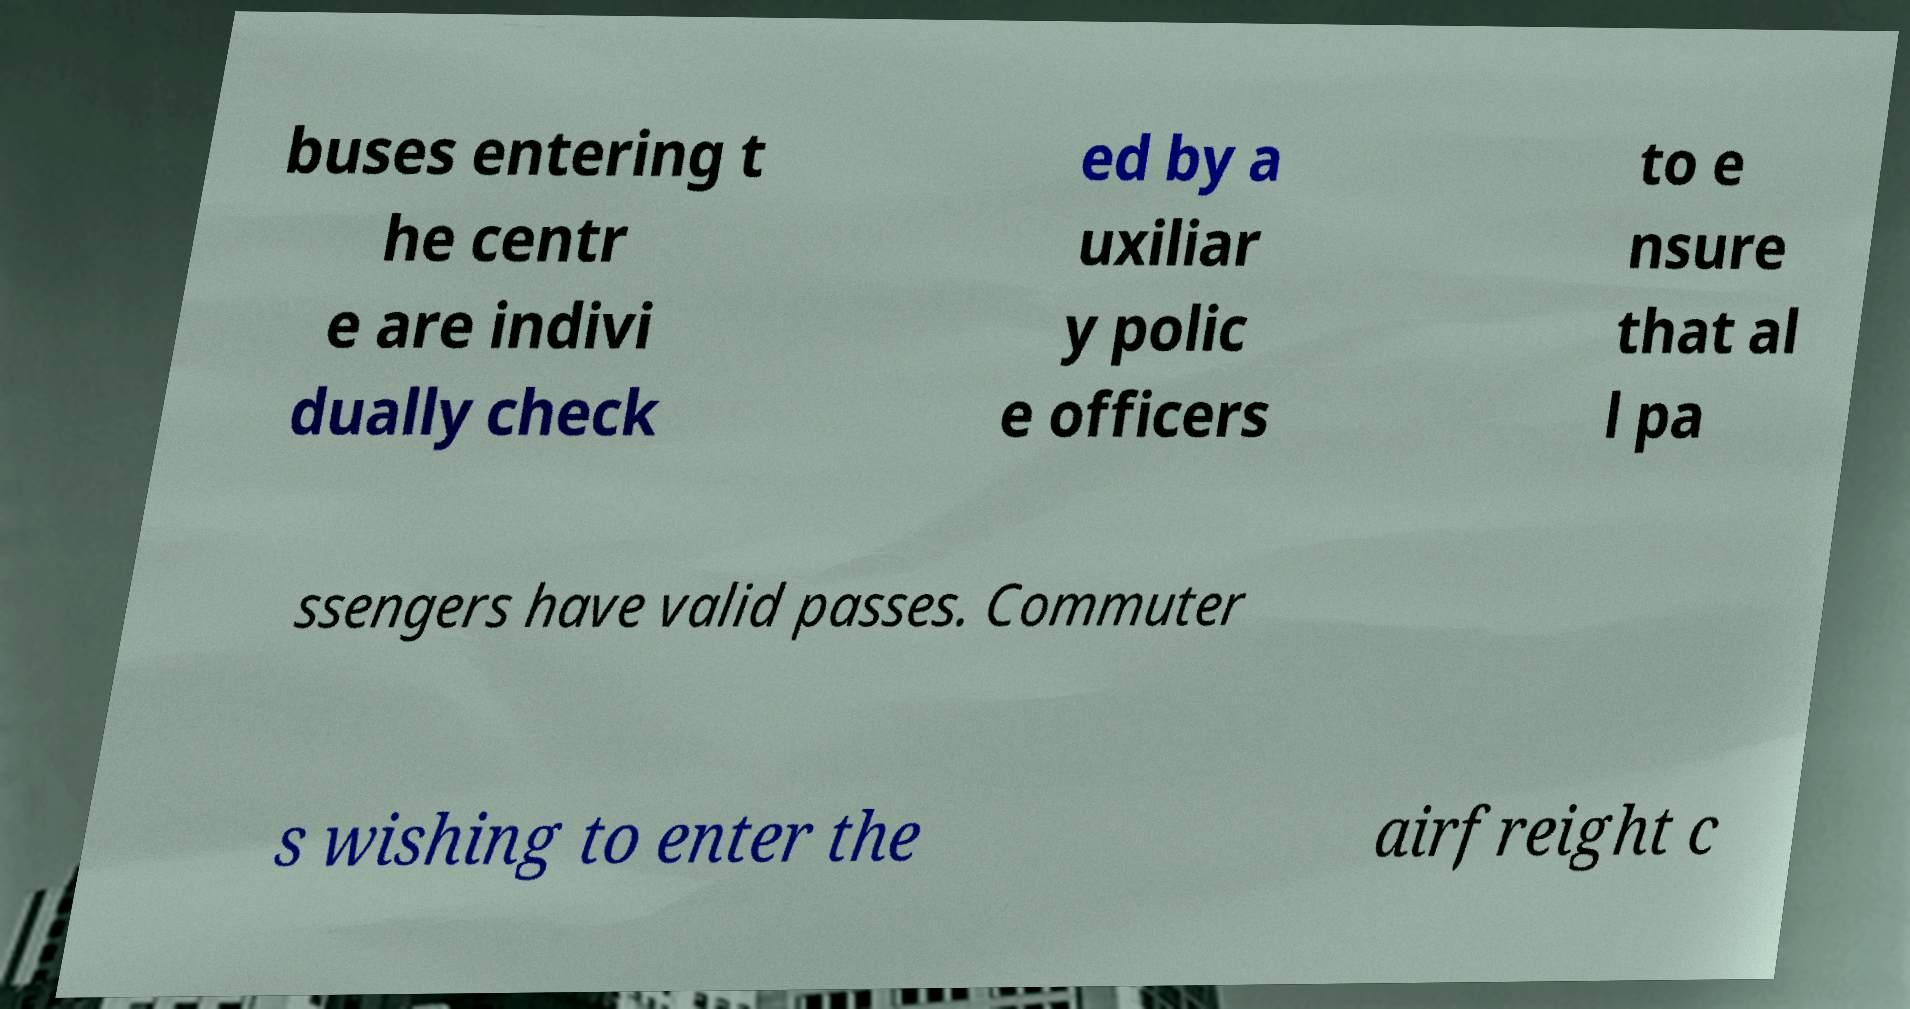Can you accurately transcribe the text from the provided image for me? buses entering t he centr e are indivi dually check ed by a uxiliar y polic e officers to e nsure that al l pa ssengers have valid passes. Commuter s wishing to enter the airfreight c 